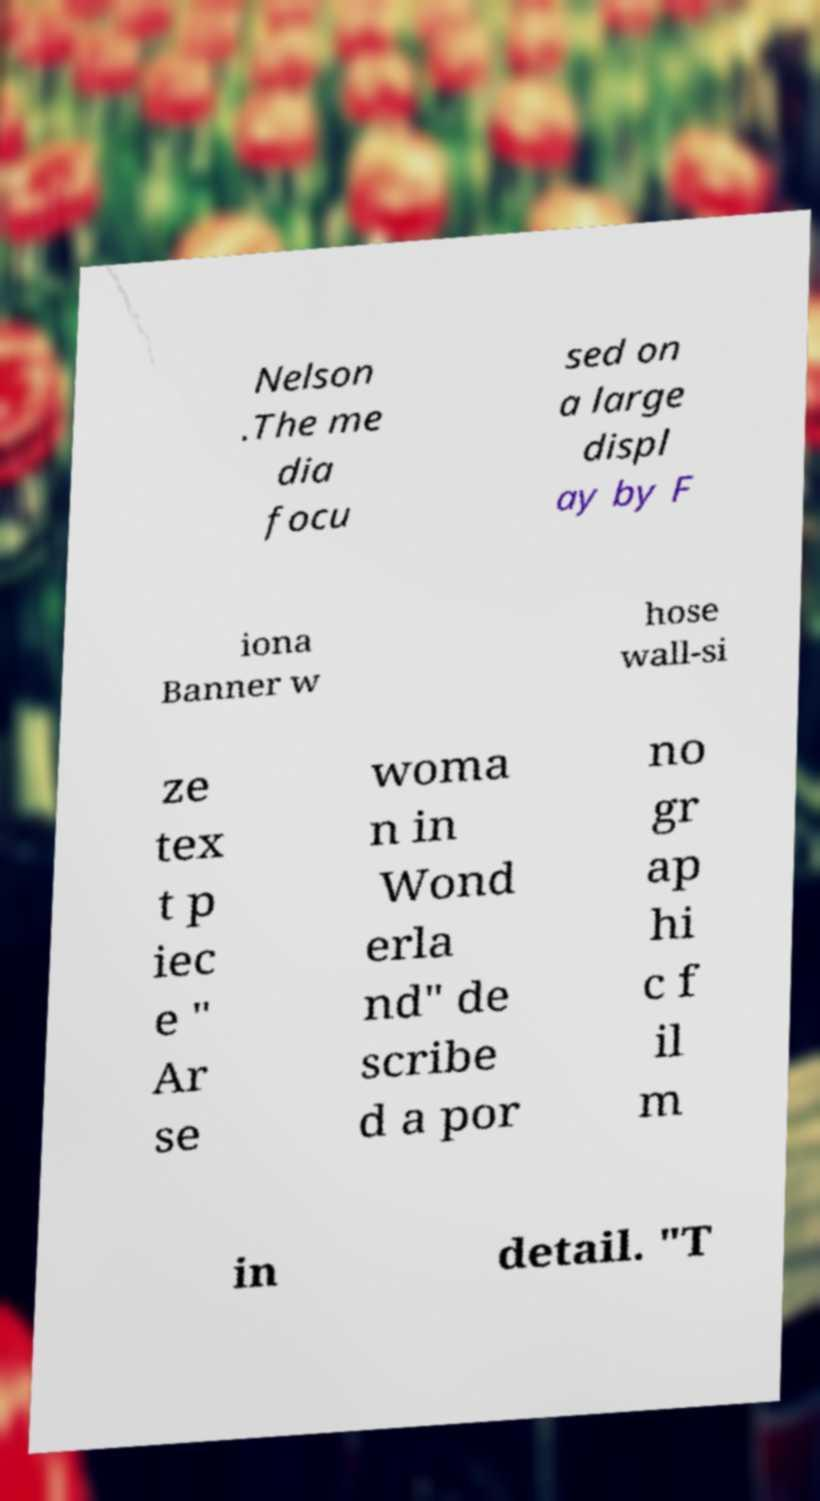Could you assist in decoding the text presented in this image and type it out clearly? Nelson .The me dia focu sed on a large displ ay by F iona Banner w hose wall-si ze tex t p iec e " Ar se woma n in Wond erla nd" de scribe d a por no gr ap hi c f il m in detail. "T 